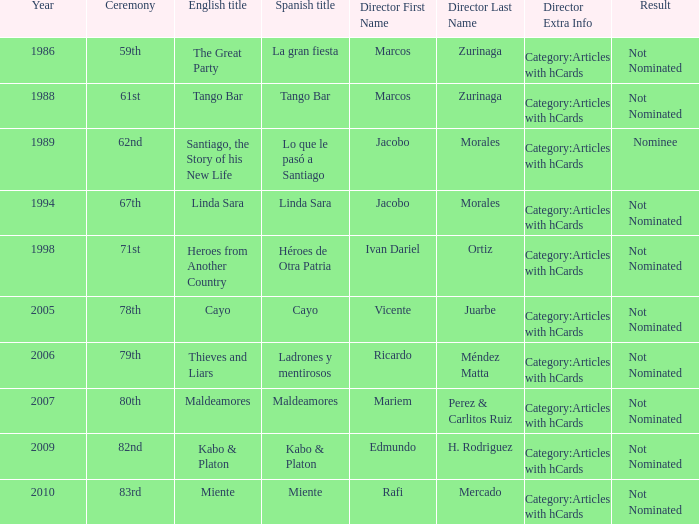What was the English title of Ladrones Y Mentirosos? Thieves and Liars. 